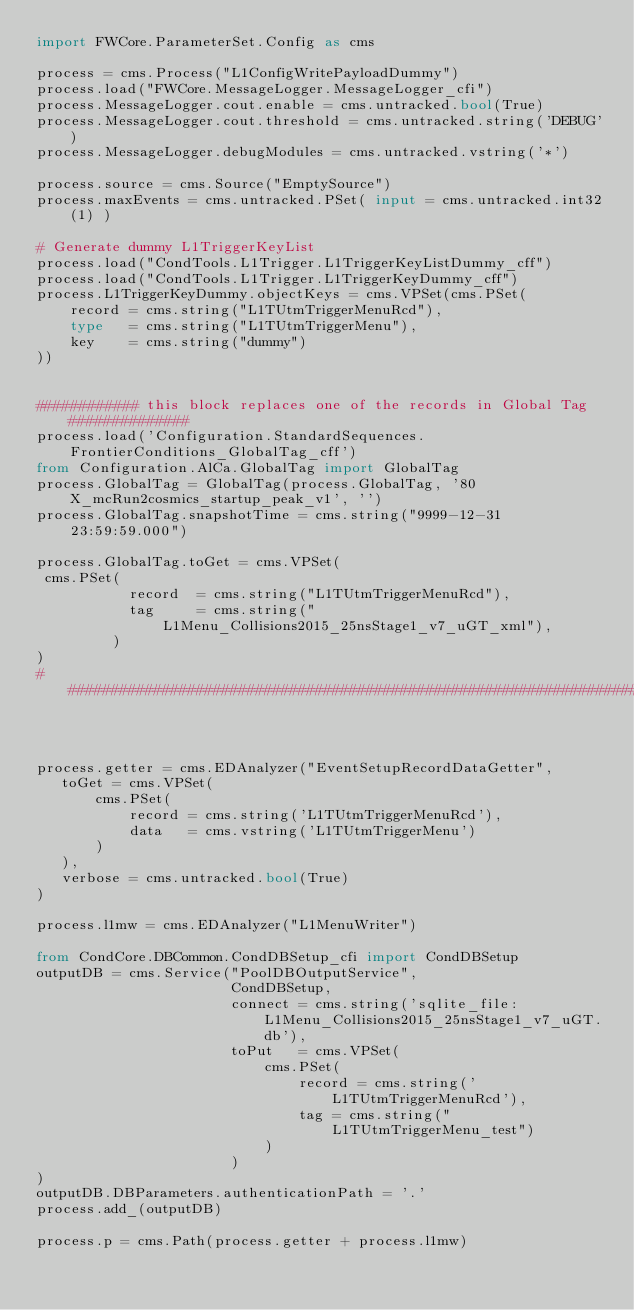Convert code to text. <code><loc_0><loc_0><loc_500><loc_500><_Python_>import FWCore.ParameterSet.Config as cms

process = cms.Process("L1ConfigWritePayloadDummy")
process.load("FWCore.MessageLogger.MessageLogger_cfi")
process.MessageLogger.cout.enable = cms.untracked.bool(True)
process.MessageLogger.cout.threshold = cms.untracked.string('DEBUG')
process.MessageLogger.debugModules = cms.untracked.vstring('*')

process.source = cms.Source("EmptySource")
process.maxEvents = cms.untracked.PSet( input = cms.untracked.int32(1) )

# Generate dummy L1TriggerKeyList
process.load("CondTools.L1Trigger.L1TriggerKeyListDummy_cff")
process.load("CondTools.L1Trigger.L1TriggerKeyDummy_cff")
process.L1TriggerKeyDummy.objectKeys = cms.VPSet(cms.PSet(
    record = cms.string("L1TUtmTriggerMenuRcd"),
    type   = cms.string("L1TUtmTriggerMenu"),
    key    = cms.string("dummy")
))


############ this block replaces one of the records in Global Tag ##############
process.load('Configuration.StandardSequences.FrontierConditions_GlobalTag_cff')
from Configuration.AlCa.GlobalTag import GlobalTag
process.GlobalTag = GlobalTag(process.GlobalTag, '80X_mcRun2cosmics_startup_peak_v1', '')
process.GlobalTag.snapshotTime = cms.string("9999-12-31 23:59:59.000")

process.GlobalTag.toGet = cms.VPSet(
 cms.PSet(
           record  = cms.string("L1TUtmTriggerMenuRcd"),
           tag     = cms.string("L1Menu_Collisions2015_25nsStage1_v7_uGT_xml"),
         )
)
################################################################################



process.getter = cms.EDAnalyzer("EventSetupRecordDataGetter",
   toGet = cms.VPSet(
       cms.PSet(
           record = cms.string('L1TUtmTriggerMenuRcd'),
           data   = cms.vstring('L1TUtmTriggerMenu')
       )
   ),
   verbose = cms.untracked.bool(True)
)

process.l1mw = cms.EDAnalyzer("L1MenuWriter")

from CondCore.DBCommon.CondDBSetup_cfi import CondDBSetup
outputDB = cms.Service("PoolDBOutputService",
                       CondDBSetup,
                       connect = cms.string('sqlite_file:L1Menu_Collisions2015_25nsStage1_v7_uGT.db'),
                       toPut   = cms.VPSet(
                           cms.PSet(
                               record = cms.string('L1TUtmTriggerMenuRcd'),
                               tag = cms.string("L1TUtmTriggerMenu_test")
                           )
                       )
)
outputDB.DBParameters.authenticationPath = '.'
process.add_(outputDB)

process.p = cms.Path(process.getter + process.l1mw)
</code> 